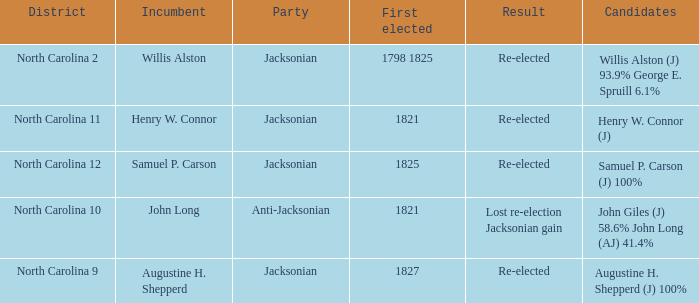9% and george e. spruill 1.0. 